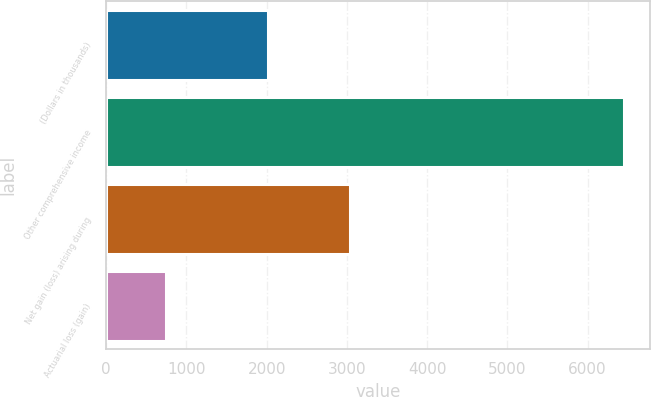Convert chart. <chart><loc_0><loc_0><loc_500><loc_500><bar_chart><fcel>(Dollars in thousands)<fcel>Other comprehensive income<fcel>Net gain (loss) arising during<fcel>Actuarial loss (gain)<nl><fcel>2013<fcel>6452<fcel>3040<fcel>739<nl></chart> 